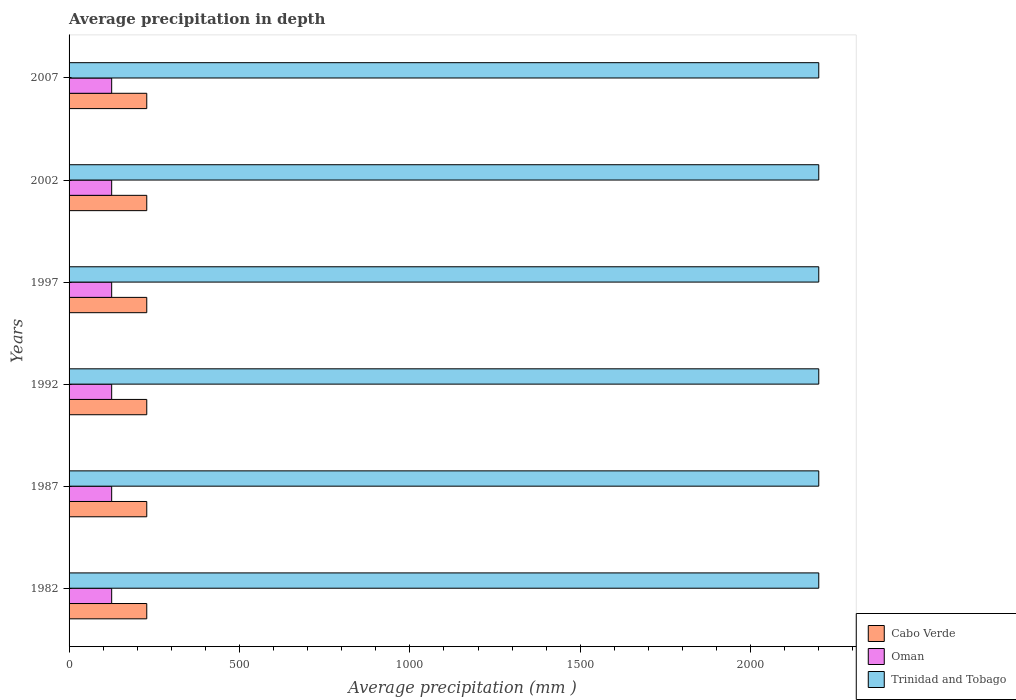How many groups of bars are there?
Make the answer very short. 6. What is the label of the 4th group of bars from the top?
Your response must be concise. 1992. What is the average precipitation in Cabo Verde in 1982?
Provide a short and direct response. 228. Across all years, what is the maximum average precipitation in Trinidad and Tobago?
Your answer should be compact. 2200. Across all years, what is the minimum average precipitation in Oman?
Keep it short and to the point. 125. In which year was the average precipitation in Cabo Verde minimum?
Ensure brevity in your answer.  1982. What is the total average precipitation in Cabo Verde in the graph?
Ensure brevity in your answer.  1368. What is the difference between the average precipitation in Cabo Verde in 1992 and that in 2007?
Ensure brevity in your answer.  0. What is the difference between the average precipitation in Cabo Verde in 1992 and the average precipitation in Oman in 1982?
Provide a short and direct response. 103. What is the average average precipitation in Trinidad and Tobago per year?
Provide a succinct answer. 2200. In the year 2002, what is the difference between the average precipitation in Cabo Verde and average precipitation in Trinidad and Tobago?
Your answer should be very brief. -1972. In how many years, is the average precipitation in Oman greater than 900 mm?
Give a very brief answer. 0. Is the average precipitation in Trinidad and Tobago in 1997 less than that in 2007?
Your response must be concise. No. Is the difference between the average precipitation in Cabo Verde in 1987 and 2002 greater than the difference between the average precipitation in Trinidad and Tobago in 1987 and 2002?
Your answer should be compact. No. What is the difference between the highest and the second highest average precipitation in Oman?
Provide a short and direct response. 0. In how many years, is the average precipitation in Cabo Verde greater than the average average precipitation in Cabo Verde taken over all years?
Your answer should be very brief. 0. Is the sum of the average precipitation in Oman in 1982 and 2007 greater than the maximum average precipitation in Trinidad and Tobago across all years?
Keep it short and to the point. No. What does the 2nd bar from the top in 1992 represents?
Offer a very short reply. Oman. What does the 3rd bar from the bottom in 1982 represents?
Your response must be concise. Trinidad and Tobago. How many years are there in the graph?
Ensure brevity in your answer.  6. What is the difference between two consecutive major ticks on the X-axis?
Provide a succinct answer. 500. Does the graph contain any zero values?
Make the answer very short. No. Where does the legend appear in the graph?
Your answer should be very brief. Bottom right. How many legend labels are there?
Your answer should be very brief. 3. What is the title of the graph?
Give a very brief answer. Average precipitation in depth. What is the label or title of the X-axis?
Give a very brief answer. Average precipitation (mm ). What is the label or title of the Y-axis?
Make the answer very short. Years. What is the Average precipitation (mm ) in Cabo Verde in 1982?
Ensure brevity in your answer.  228. What is the Average precipitation (mm ) in Oman in 1982?
Keep it short and to the point. 125. What is the Average precipitation (mm ) of Trinidad and Tobago in 1982?
Offer a very short reply. 2200. What is the Average precipitation (mm ) of Cabo Verde in 1987?
Offer a terse response. 228. What is the Average precipitation (mm ) in Oman in 1987?
Make the answer very short. 125. What is the Average precipitation (mm ) in Trinidad and Tobago in 1987?
Offer a terse response. 2200. What is the Average precipitation (mm ) of Cabo Verde in 1992?
Provide a succinct answer. 228. What is the Average precipitation (mm ) of Oman in 1992?
Keep it short and to the point. 125. What is the Average precipitation (mm ) in Trinidad and Tobago in 1992?
Ensure brevity in your answer.  2200. What is the Average precipitation (mm ) in Cabo Verde in 1997?
Make the answer very short. 228. What is the Average precipitation (mm ) in Oman in 1997?
Give a very brief answer. 125. What is the Average precipitation (mm ) of Trinidad and Tobago in 1997?
Give a very brief answer. 2200. What is the Average precipitation (mm ) of Cabo Verde in 2002?
Give a very brief answer. 228. What is the Average precipitation (mm ) of Oman in 2002?
Make the answer very short. 125. What is the Average precipitation (mm ) of Trinidad and Tobago in 2002?
Make the answer very short. 2200. What is the Average precipitation (mm ) of Cabo Verde in 2007?
Make the answer very short. 228. What is the Average precipitation (mm ) of Oman in 2007?
Give a very brief answer. 125. What is the Average precipitation (mm ) of Trinidad and Tobago in 2007?
Provide a short and direct response. 2200. Across all years, what is the maximum Average precipitation (mm ) in Cabo Verde?
Offer a very short reply. 228. Across all years, what is the maximum Average precipitation (mm ) of Oman?
Offer a very short reply. 125. Across all years, what is the maximum Average precipitation (mm ) of Trinidad and Tobago?
Provide a short and direct response. 2200. Across all years, what is the minimum Average precipitation (mm ) of Cabo Verde?
Provide a succinct answer. 228. Across all years, what is the minimum Average precipitation (mm ) in Oman?
Provide a short and direct response. 125. Across all years, what is the minimum Average precipitation (mm ) in Trinidad and Tobago?
Ensure brevity in your answer.  2200. What is the total Average precipitation (mm ) of Cabo Verde in the graph?
Ensure brevity in your answer.  1368. What is the total Average precipitation (mm ) in Oman in the graph?
Ensure brevity in your answer.  750. What is the total Average precipitation (mm ) of Trinidad and Tobago in the graph?
Keep it short and to the point. 1.32e+04. What is the difference between the Average precipitation (mm ) of Cabo Verde in 1982 and that in 1987?
Your answer should be compact. 0. What is the difference between the Average precipitation (mm ) in Oman in 1982 and that in 1992?
Offer a terse response. 0. What is the difference between the Average precipitation (mm ) of Oman in 1982 and that in 1997?
Offer a terse response. 0. What is the difference between the Average precipitation (mm ) of Trinidad and Tobago in 1982 and that in 1997?
Make the answer very short. 0. What is the difference between the Average precipitation (mm ) in Oman in 1982 and that in 2007?
Ensure brevity in your answer.  0. What is the difference between the Average precipitation (mm ) of Trinidad and Tobago in 1982 and that in 2007?
Keep it short and to the point. 0. What is the difference between the Average precipitation (mm ) of Cabo Verde in 1987 and that in 1992?
Offer a terse response. 0. What is the difference between the Average precipitation (mm ) in Trinidad and Tobago in 1987 and that in 1992?
Give a very brief answer. 0. What is the difference between the Average precipitation (mm ) of Cabo Verde in 1987 and that in 1997?
Provide a short and direct response. 0. What is the difference between the Average precipitation (mm ) of Oman in 1987 and that in 1997?
Your answer should be very brief. 0. What is the difference between the Average precipitation (mm ) of Trinidad and Tobago in 1987 and that in 1997?
Keep it short and to the point. 0. What is the difference between the Average precipitation (mm ) in Cabo Verde in 1987 and that in 2002?
Provide a succinct answer. 0. What is the difference between the Average precipitation (mm ) of Oman in 1987 and that in 2002?
Offer a very short reply. 0. What is the difference between the Average precipitation (mm ) in Oman in 1987 and that in 2007?
Ensure brevity in your answer.  0. What is the difference between the Average precipitation (mm ) of Cabo Verde in 1992 and that in 1997?
Your answer should be compact. 0. What is the difference between the Average precipitation (mm ) of Oman in 1992 and that in 1997?
Give a very brief answer. 0. What is the difference between the Average precipitation (mm ) in Trinidad and Tobago in 1992 and that in 1997?
Make the answer very short. 0. What is the difference between the Average precipitation (mm ) of Cabo Verde in 1992 and that in 2002?
Provide a succinct answer. 0. What is the difference between the Average precipitation (mm ) of Oman in 1992 and that in 2002?
Your response must be concise. 0. What is the difference between the Average precipitation (mm ) in Trinidad and Tobago in 1992 and that in 2002?
Ensure brevity in your answer.  0. What is the difference between the Average precipitation (mm ) of Oman in 1997 and that in 2007?
Give a very brief answer. 0. What is the difference between the Average precipitation (mm ) in Trinidad and Tobago in 1997 and that in 2007?
Your answer should be very brief. 0. What is the difference between the Average precipitation (mm ) in Cabo Verde in 2002 and that in 2007?
Your response must be concise. 0. What is the difference between the Average precipitation (mm ) of Cabo Verde in 1982 and the Average precipitation (mm ) of Oman in 1987?
Your answer should be compact. 103. What is the difference between the Average precipitation (mm ) of Cabo Verde in 1982 and the Average precipitation (mm ) of Trinidad and Tobago in 1987?
Provide a succinct answer. -1972. What is the difference between the Average precipitation (mm ) in Oman in 1982 and the Average precipitation (mm ) in Trinidad and Tobago in 1987?
Your answer should be compact. -2075. What is the difference between the Average precipitation (mm ) in Cabo Verde in 1982 and the Average precipitation (mm ) in Oman in 1992?
Ensure brevity in your answer.  103. What is the difference between the Average precipitation (mm ) of Cabo Verde in 1982 and the Average precipitation (mm ) of Trinidad and Tobago in 1992?
Your answer should be very brief. -1972. What is the difference between the Average precipitation (mm ) of Oman in 1982 and the Average precipitation (mm ) of Trinidad and Tobago in 1992?
Make the answer very short. -2075. What is the difference between the Average precipitation (mm ) of Cabo Verde in 1982 and the Average precipitation (mm ) of Oman in 1997?
Provide a succinct answer. 103. What is the difference between the Average precipitation (mm ) of Cabo Verde in 1982 and the Average precipitation (mm ) of Trinidad and Tobago in 1997?
Offer a very short reply. -1972. What is the difference between the Average precipitation (mm ) in Oman in 1982 and the Average precipitation (mm ) in Trinidad and Tobago in 1997?
Provide a succinct answer. -2075. What is the difference between the Average precipitation (mm ) in Cabo Verde in 1982 and the Average precipitation (mm ) in Oman in 2002?
Your answer should be compact. 103. What is the difference between the Average precipitation (mm ) in Cabo Verde in 1982 and the Average precipitation (mm ) in Trinidad and Tobago in 2002?
Your answer should be compact. -1972. What is the difference between the Average precipitation (mm ) in Oman in 1982 and the Average precipitation (mm ) in Trinidad and Tobago in 2002?
Provide a short and direct response. -2075. What is the difference between the Average precipitation (mm ) in Cabo Verde in 1982 and the Average precipitation (mm ) in Oman in 2007?
Make the answer very short. 103. What is the difference between the Average precipitation (mm ) in Cabo Verde in 1982 and the Average precipitation (mm ) in Trinidad and Tobago in 2007?
Keep it short and to the point. -1972. What is the difference between the Average precipitation (mm ) in Oman in 1982 and the Average precipitation (mm ) in Trinidad and Tobago in 2007?
Your answer should be compact. -2075. What is the difference between the Average precipitation (mm ) in Cabo Verde in 1987 and the Average precipitation (mm ) in Oman in 1992?
Your answer should be compact. 103. What is the difference between the Average precipitation (mm ) in Cabo Verde in 1987 and the Average precipitation (mm ) in Trinidad and Tobago in 1992?
Ensure brevity in your answer.  -1972. What is the difference between the Average precipitation (mm ) in Oman in 1987 and the Average precipitation (mm ) in Trinidad and Tobago in 1992?
Provide a short and direct response. -2075. What is the difference between the Average precipitation (mm ) in Cabo Verde in 1987 and the Average precipitation (mm ) in Oman in 1997?
Provide a short and direct response. 103. What is the difference between the Average precipitation (mm ) in Cabo Verde in 1987 and the Average precipitation (mm ) in Trinidad and Tobago in 1997?
Your response must be concise. -1972. What is the difference between the Average precipitation (mm ) in Oman in 1987 and the Average precipitation (mm ) in Trinidad and Tobago in 1997?
Ensure brevity in your answer.  -2075. What is the difference between the Average precipitation (mm ) of Cabo Verde in 1987 and the Average precipitation (mm ) of Oman in 2002?
Offer a very short reply. 103. What is the difference between the Average precipitation (mm ) in Cabo Verde in 1987 and the Average precipitation (mm ) in Trinidad and Tobago in 2002?
Make the answer very short. -1972. What is the difference between the Average precipitation (mm ) in Oman in 1987 and the Average precipitation (mm ) in Trinidad and Tobago in 2002?
Offer a terse response. -2075. What is the difference between the Average precipitation (mm ) in Cabo Verde in 1987 and the Average precipitation (mm ) in Oman in 2007?
Make the answer very short. 103. What is the difference between the Average precipitation (mm ) of Cabo Verde in 1987 and the Average precipitation (mm ) of Trinidad and Tobago in 2007?
Provide a succinct answer. -1972. What is the difference between the Average precipitation (mm ) in Oman in 1987 and the Average precipitation (mm ) in Trinidad and Tobago in 2007?
Your answer should be very brief. -2075. What is the difference between the Average precipitation (mm ) in Cabo Verde in 1992 and the Average precipitation (mm ) in Oman in 1997?
Keep it short and to the point. 103. What is the difference between the Average precipitation (mm ) of Cabo Verde in 1992 and the Average precipitation (mm ) of Trinidad and Tobago in 1997?
Offer a terse response. -1972. What is the difference between the Average precipitation (mm ) of Oman in 1992 and the Average precipitation (mm ) of Trinidad and Tobago in 1997?
Offer a very short reply. -2075. What is the difference between the Average precipitation (mm ) in Cabo Verde in 1992 and the Average precipitation (mm ) in Oman in 2002?
Your response must be concise. 103. What is the difference between the Average precipitation (mm ) in Cabo Verde in 1992 and the Average precipitation (mm ) in Trinidad and Tobago in 2002?
Offer a terse response. -1972. What is the difference between the Average precipitation (mm ) in Oman in 1992 and the Average precipitation (mm ) in Trinidad and Tobago in 2002?
Provide a short and direct response. -2075. What is the difference between the Average precipitation (mm ) in Cabo Verde in 1992 and the Average precipitation (mm ) in Oman in 2007?
Offer a terse response. 103. What is the difference between the Average precipitation (mm ) in Cabo Verde in 1992 and the Average precipitation (mm ) in Trinidad and Tobago in 2007?
Provide a short and direct response. -1972. What is the difference between the Average precipitation (mm ) in Oman in 1992 and the Average precipitation (mm ) in Trinidad and Tobago in 2007?
Ensure brevity in your answer.  -2075. What is the difference between the Average precipitation (mm ) of Cabo Verde in 1997 and the Average precipitation (mm ) of Oman in 2002?
Your answer should be compact. 103. What is the difference between the Average precipitation (mm ) in Cabo Verde in 1997 and the Average precipitation (mm ) in Trinidad and Tobago in 2002?
Make the answer very short. -1972. What is the difference between the Average precipitation (mm ) in Oman in 1997 and the Average precipitation (mm ) in Trinidad and Tobago in 2002?
Provide a succinct answer. -2075. What is the difference between the Average precipitation (mm ) of Cabo Verde in 1997 and the Average precipitation (mm ) of Oman in 2007?
Your response must be concise. 103. What is the difference between the Average precipitation (mm ) in Cabo Verde in 1997 and the Average precipitation (mm ) in Trinidad and Tobago in 2007?
Offer a terse response. -1972. What is the difference between the Average precipitation (mm ) in Oman in 1997 and the Average precipitation (mm ) in Trinidad and Tobago in 2007?
Provide a short and direct response. -2075. What is the difference between the Average precipitation (mm ) in Cabo Verde in 2002 and the Average precipitation (mm ) in Oman in 2007?
Your answer should be compact. 103. What is the difference between the Average precipitation (mm ) of Cabo Verde in 2002 and the Average precipitation (mm ) of Trinidad and Tobago in 2007?
Keep it short and to the point. -1972. What is the difference between the Average precipitation (mm ) in Oman in 2002 and the Average precipitation (mm ) in Trinidad and Tobago in 2007?
Provide a succinct answer. -2075. What is the average Average precipitation (mm ) in Cabo Verde per year?
Offer a terse response. 228. What is the average Average precipitation (mm ) in Oman per year?
Your response must be concise. 125. What is the average Average precipitation (mm ) in Trinidad and Tobago per year?
Offer a very short reply. 2200. In the year 1982, what is the difference between the Average precipitation (mm ) in Cabo Verde and Average precipitation (mm ) in Oman?
Ensure brevity in your answer.  103. In the year 1982, what is the difference between the Average precipitation (mm ) in Cabo Verde and Average precipitation (mm ) in Trinidad and Tobago?
Provide a short and direct response. -1972. In the year 1982, what is the difference between the Average precipitation (mm ) in Oman and Average precipitation (mm ) in Trinidad and Tobago?
Ensure brevity in your answer.  -2075. In the year 1987, what is the difference between the Average precipitation (mm ) of Cabo Verde and Average precipitation (mm ) of Oman?
Provide a short and direct response. 103. In the year 1987, what is the difference between the Average precipitation (mm ) in Cabo Verde and Average precipitation (mm ) in Trinidad and Tobago?
Your answer should be compact. -1972. In the year 1987, what is the difference between the Average precipitation (mm ) of Oman and Average precipitation (mm ) of Trinidad and Tobago?
Give a very brief answer. -2075. In the year 1992, what is the difference between the Average precipitation (mm ) of Cabo Verde and Average precipitation (mm ) of Oman?
Your answer should be compact. 103. In the year 1992, what is the difference between the Average precipitation (mm ) in Cabo Verde and Average precipitation (mm ) in Trinidad and Tobago?
Your answer should be very brief. -1972. In the year 1992, what is the difference between the Average precipitation (mm ) in Oman and Average precipitation (mm ) in Trinidad and Tobago?
Provide a succinct answer. -2075. In the year 1997, what is the difference between the Average precipitation (mm ) of Cabo Verde and Average precipitation (mm ) of Oman?
Offer a very short reply. 103. In the year 1997, what is the difference between the Average precipitation (mm ) in Cabo Verde and Average precipitation (mm ) in Trinidad and Tobago?
Offer a very short reply. -1972. In the year 1997, what is the difference between the Average precipitation (mm ) in Oman and Average precipitation (mm ) in Trinidad and Tobago?
Ensure brevity in your answer.  -2075. In the year 2002, what is the difference between the Average precipitation (mm ) of Cabo Verde and Average precipitation (mm ) of Oman?
Provide a short and direct response. 103. In the year 2002, what is the difference between the Average precipitation (mm ) in Cabo Verde and Average precipitation (mm ) in Trinidad and Tobago?
Give a very brief answer. -1972. In the year 2002, what is the difference between the Average precipitation (mm ) of Oman and Average precipitation (mm ) of Trinidad and Tobago?
Give a very brief answer. -2075. In the year 2007, what is the difference between the Average precipitation (mm ) of Cabo Verde and Average precipitation (mm ) of Oman?
Ensure brevity in your answer.  103. In the year 2007, what is the difference between the Average precipitation (mm ) of Cabo Verde and Average precipitation (mm ) of Trinidad and Tobago?
Make the answer very short. -1972. In the year 2007, what is the difference between the Average precipitation (mm ) in Oman and Average precipitation (mm ) in Trinidad and Tobago?
Provide a short and direct response. -2075. What is the ratio of the Average precipitation (mm ) of Cabo Verde in 1982 to that in 1987?
Give a very brief answer. 1. What is the ratio of the Average precipitation (mm ) of Oman in 1982 to that in 1992?
Make the answer very short. 1. What is the ratio of the Average precipitation (mm ) of Trinidad and Tobago in 1982 to that in 1992?
Ensure brevity in your answer.  1. What is the ratio of the Average precipitation (mm ) of Trinidad and Tobago in 1982 to that in 1997?
Provide a short and direct response. 1. What is the ratio of the Average precipitation (mm ) in Cabo Verde in 1982 to that in 2002?
Offer a terse response. 1. What is the ratio of the Average precipitation (mm ) of Oman in 1982 to that in 2002?
Ensure brevity in your answer.  1. What is the ratio of the Average precipitation (mm ) of Cabo Verde in 1982 to that in 2007?
Make the answer very short. 1. What is the ratio of the Average precipitation (mm ) in Oman in 1982 to that in 2007?
Give a very brief answer. 1. What is the ratio of the Average precipitation (mm ) in Trinidad and Tobago in 1982 to that in 2007?
Make the answer very short. 1. What is the ratio of the Average precipitation (mm ) of Cabo Verde in 1987 to that in 1992?
Keep it short and to the point. 1. What is the ratio of the Average precipitation (mm ) of Oman in 1987 to that in 1992?
Make the answer very short. 1. What is the ratio of the Average precipitation (mm ) in Trinidad and Tobago in 1987 to that in 1992?
Keep it short and to the point. 1. What is the ratio of the Average precipitation (mm ) of Cabo Verde in 1987 to that in 1997?
Your response must be concise. 1. What is the ratio of the Average precipitation (mm ) of Oman in 1987 to that in 1997?
Your answer should be compact. 1. What is the ratio of the Average precipitation (mm ) in Cabo Verde in 1987 to that in 2002?
Make the answer very short. 1. What is the ratio of the Average precipitation (mm ) of Cabo Verde in 1987 to that in 2007?
Your response must be concise. 1. What is the ratio of the Average precipitation (mm ) of Trinidad and Tobago in 1987 to that in 2007?
Ensure brevity in your answer.  1. What is the ratio of the Average precipitation (mm ) of Trinidad and Tobago in 1992 to that in 1997?
Your answer should be very brief. 1. What is the ratio of the Average precipitation (mm ) in Cabo Verde in 1992 to that in 2002?
Your answer should be compact. 1. What is the ratio of the Average precipitation (mm ) of Trinidad and Tobago in 1992 to that in 2002?
Offer a terse response. 1. What is the ratio of the Average precipitation (mm ) in Trinidad and Tobago in 1992 to that in 2007?
Offer a terse response. 1. What is the ratio of the Average precipitation (mm ) in Cabo Verde in 1997 to that in 2007?
Ensure brevity in your answer.  1. What is the ratio of the Average precipitation (mm ) of Trinidad and Tobago in 1997 to that in 2007?
Give a very brief answer. 1. What is the ratio of the Average precipitation (mm ) in Cabo Verde in 2002 to that in 2007?
Make the answer very short. 1. What is the difference between the highest and the second highest Average precipitation (mm ) in Oman?
Give a very brief answer. 0. What is the difference between the highest and the lowest Average precipitation (mm ) in Oman?
Offer a terse response. 0. 